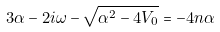Convert formula to latex. <formula><loc_0><loc_0><loc_500><loc_500>3 \alpha - 2 i \omega - \sqrt { \alpha ^ { 2 } - 4 V _ { 0 } } = - 4 n \alpha</formula> 